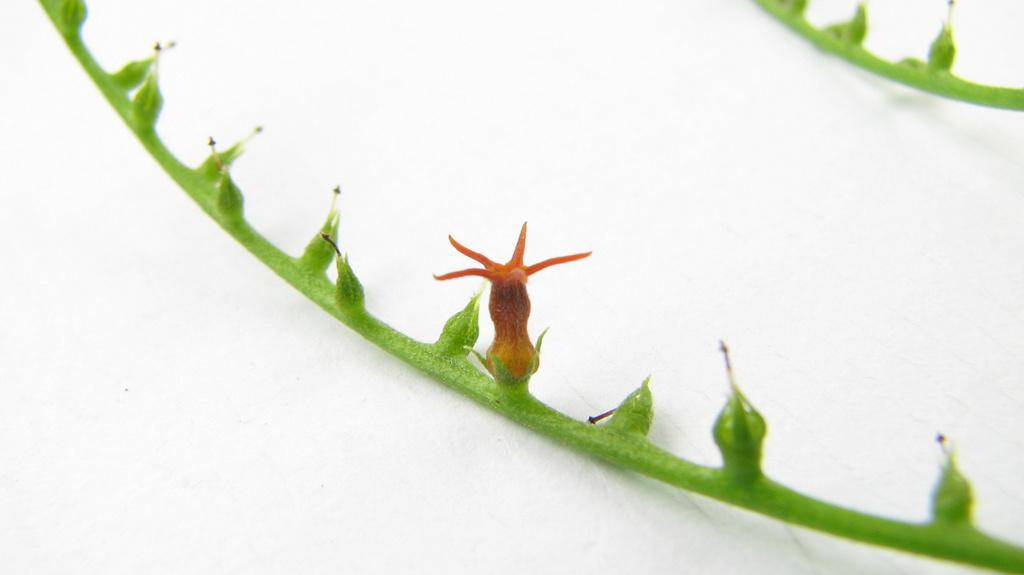How many stems can be seen in the image? There are 2 stems in the image. What is present along with the stems? There is a flower in the image. What is the color of the surface on which the stems and flower are placed? The stems and flower are on a white surface. What type of patch can be seen on the basketball in the image? There is no basketball present in the image; it only features stems and a flower on a white surface. 